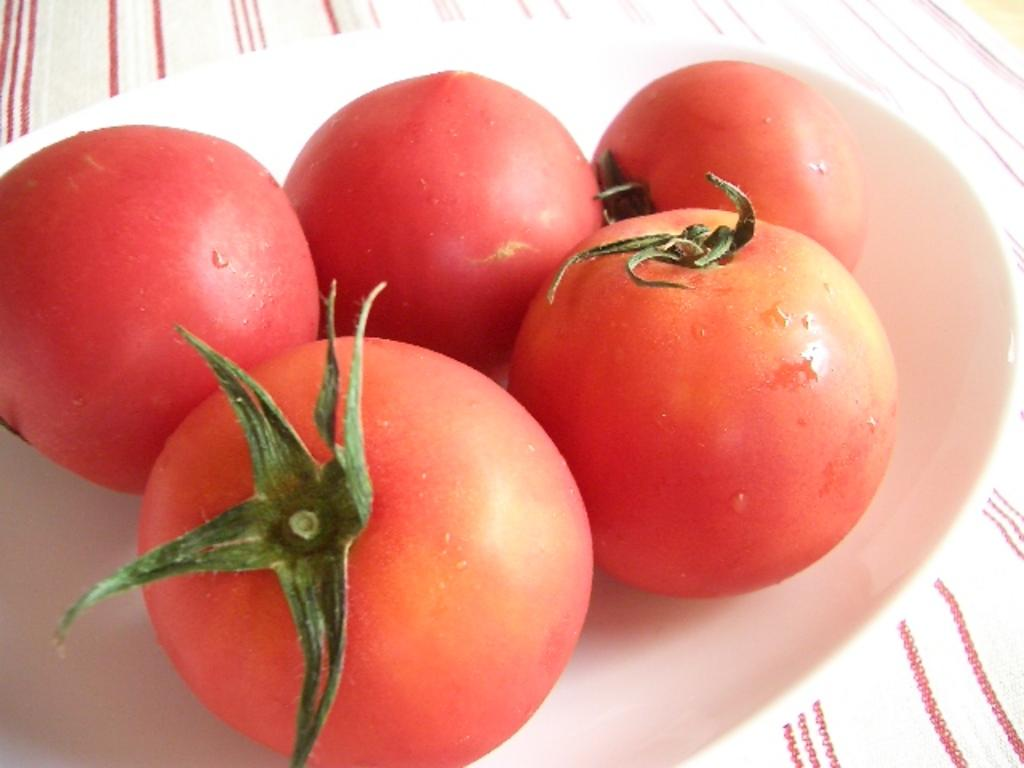What is present on the plate in the image? There are tomatoes on the plate. Can you describe the main object on the plate? The main object on the plate is tomatoes. What type of sound can be heard coming from the tomatoes in the image? There is no sound coming from the tomatoes in the image, as they are a still image and do not produce sound. 